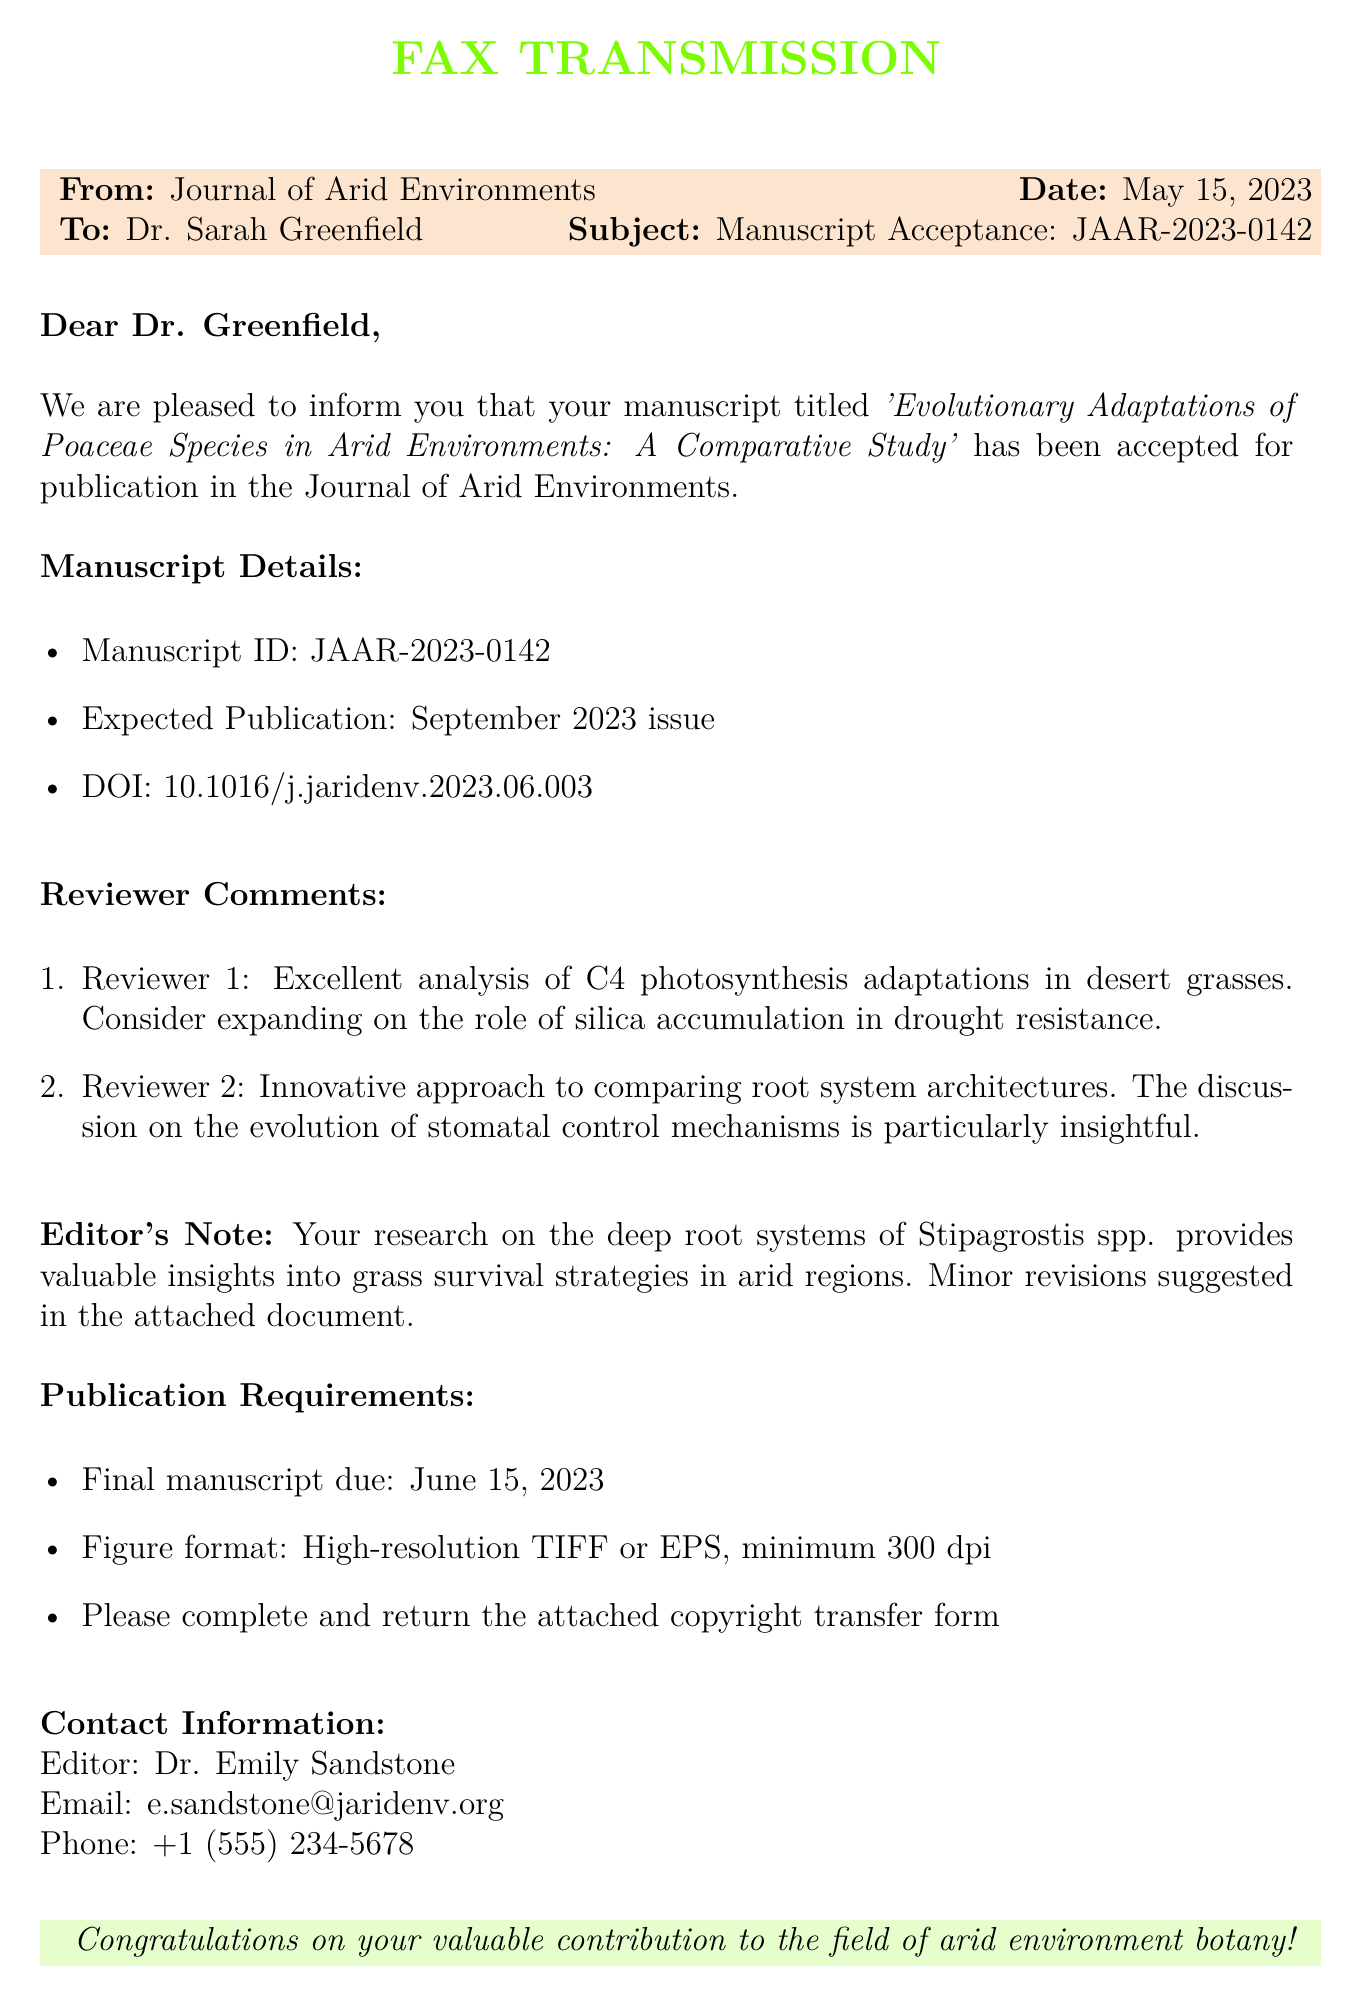What is the manuscript ID? The manuscript ID is highlighted in the manuscript details section of the fax as JAAR-2023-0142.
Answer: JAAR-2023-0142 When is the expected publication date? The expected publication date is specified in the manuscript details section as September 2023 issue.
Answer: September 2023 Who is the editor of the journal? The name of the editor, Dr. Emily Sandstone, is stated in the contact information section of the fax.
Answer: Dr. Emily Sandstone What comments did Reviewer 1 provide? Reviewer 1's comment can be found in the reviewer comments section, specifically mentioning C4 photosynthesis adaptations.
Answer: Excellent analysis of C4 photosynthesis adaptations in desert grasses What is the due date for the final manuscript? The due date is mentioned in the publication requirements section of the fax as June 15, 2023.
Answer: June 15, 2023 What is the DOI for the manuscript? The DOI is listed in the manuscript details section and is essential for reference and access.
Answer: 10.1016/j.jaridenv.2023.06.003 What minor revisions are suggested? The editor's note highlights that minor revisions are suggested but does not specify them in the fax; they are in the attached document.
Answer: Minor revisions suggested in the attached document How should the figures be formatted? The publication requirements section details that figures must be in a high-resolution format specified.
Answer: High-resolution TIFF or EPS, minimum 300 dpi What is the significance of the research? The editor's note emphasizes the valuable insights into survival strategies provided by the research.
Answer: Valuable insights into grass survival strategies in arid regions 